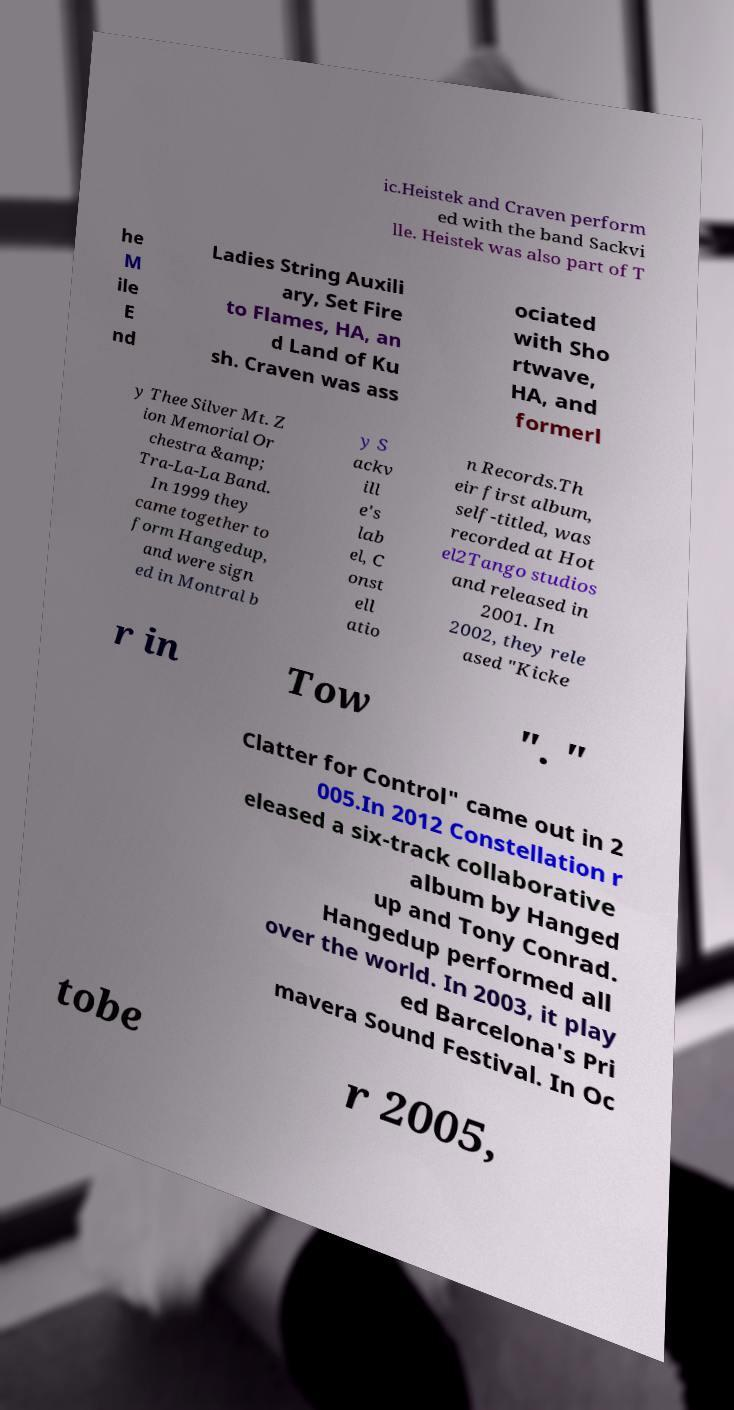Can you accurately transcribe the text from the provided image for me? ic.Heistek and Craven perform ed with the band Sackvi lle. Heistek was also part of T he M ile E nd Ladies String Auxili ary, Set Fire to Flames, HA, an d Land of Ku sh. Craven was ass ociated with Sho rtwave, HA, and formerl y Thee Silver Mt. Z ion Memorial Or chestra &amp; Tra-La-La Band. In 1999 they came together to form Hangedup, and were sign ed in Montral b y S ackv ill e's lab el, C onst ell atio n Records.Th eir first album, self-titled, was recorded at Hot el2Tango studios and released in 2001. In 2002, they rele ased "Kicke r in Tow ". " Clatter for Control" came out in 2 005.In 2012 Constellation r eleased a six-track collaborative album by Hanged up and Tony Conrad. Hangedup performed all over the world. In 2003, it play ed Barcelona's Pri mavera Sound Festival. In Oc tobe r 2005, 